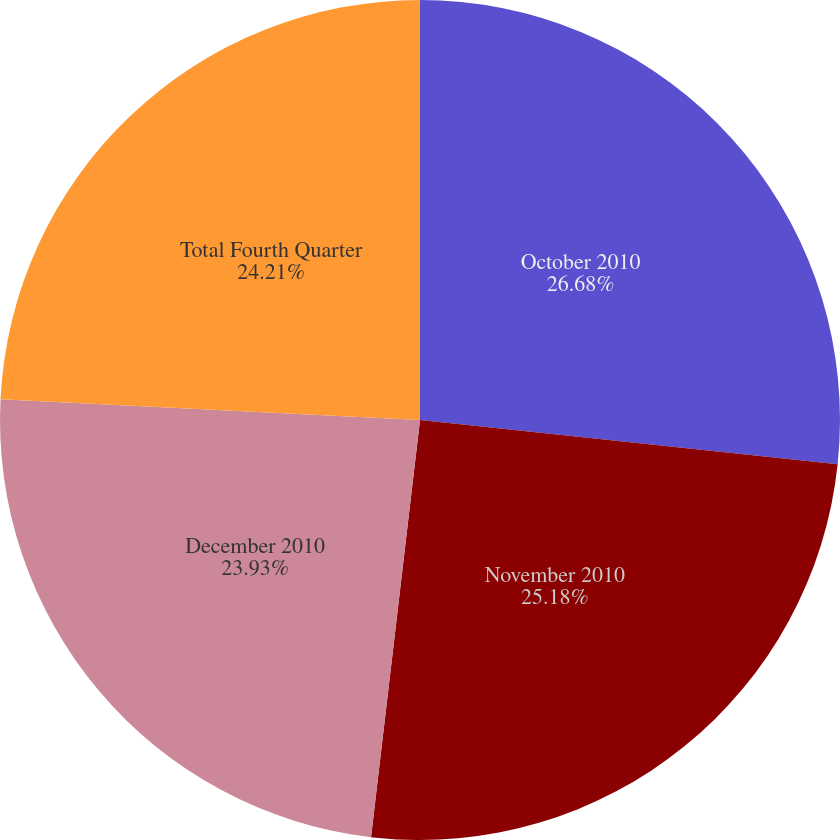Convert chart to OTSL. <chart><loc_0><loc_0><loc_500><loc_500><pie_chart><fcel>October 2010<fcel>November 2010<fcel>December 2010<fcel>Total Fourth Quarter<nl><fcel>26.68%<fcel>25.18%<fcel>23.93%<fcel>24.21%<nl></chart> 